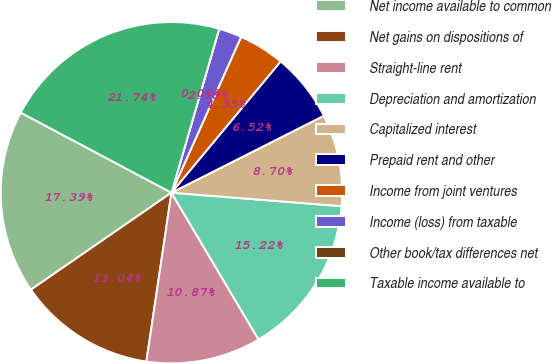<chart> <loc_0><loc_0><loc_500><loc_500><pie_chart><fcel>Net income available to common<fcel>Net gains on dispositions of<fcel>Straight-line rent<fcel>Depreciation and amortization<fcel>Capitalized interest<fcel>Prepaid rent and other<fcel>Income from joint ventures<fcel>Income (loss) from taxable<fcel>Other book/tax differences net<fcel>Taxable income available to<nl><fcel>17.39%<fcel>13.04%<fcel>10.87%<fcel>15.22%<fcel>8.7%<fcel>6.52%<fcel>4.35%<fcel>2.18%<fcel>0.0%<fcel>21.74%<nl></chart> 